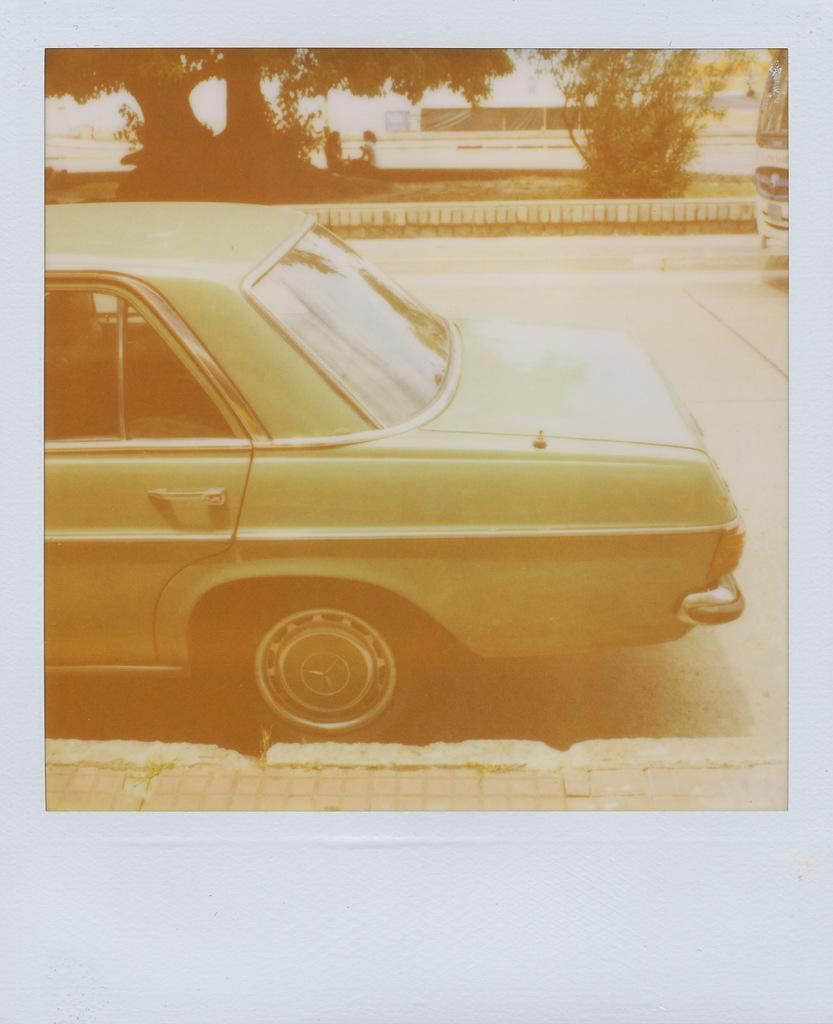What is the main subject of the photo in the image? The photo contains a car on the road. What can be seen in the background of the photo? There are trees and a building in the background of the photo. Can you see any bubbles in the photo? There are no bubbles present in the photo; it features a car on the road with trees and a building in the background. 